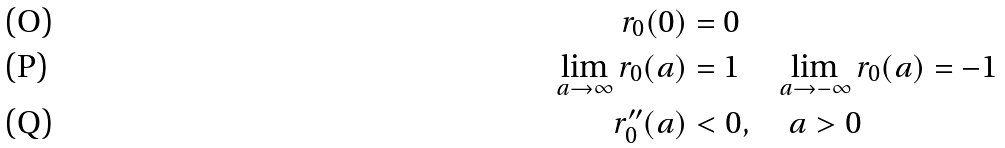Convert formula to latex. <formula><loc_0><loc_0><loc_500><loc_500>r _ { 0 } ( 0 ) & = 0 \\ \lim _ { a \to \infty } r _ { 0 } ( a ) & = 1 \quad \lim _ { a \to - \infty } r _ { 0 } ( a ) = - 1 \\ r _ { 0 } ^ { \prime \prime } ( a ) & < 0 , \quad a > 0</formula> 